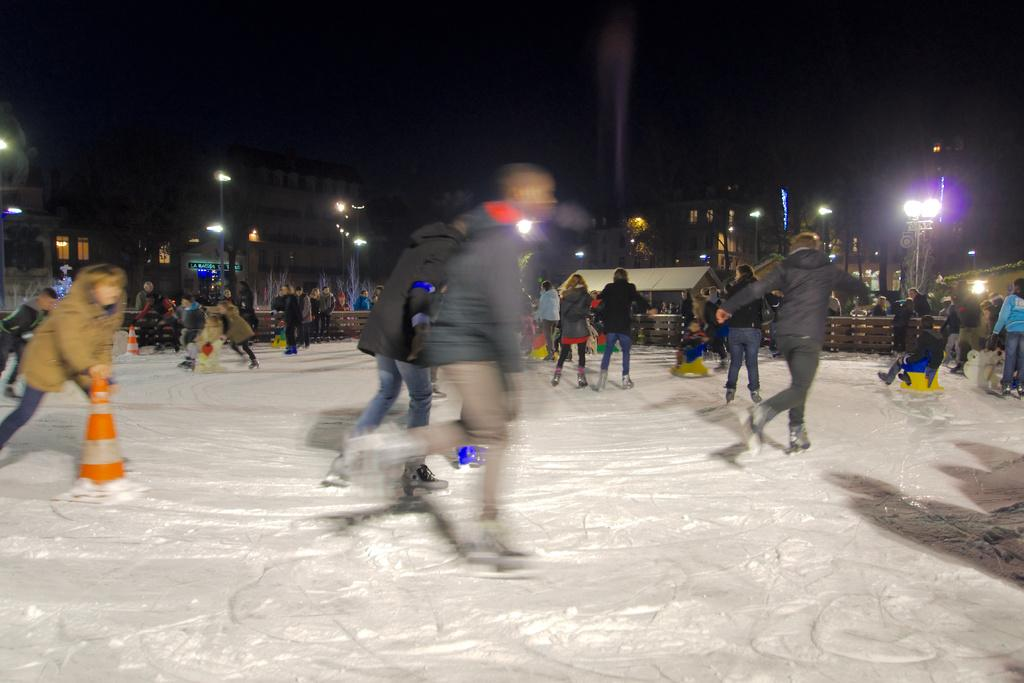What type of footwear are the people wearing in the image? The people are wearing ski shoes in the image. What objects are present in the foreground of the image? There are traffic cones and fencing in the foreground of the image. What can be seen in the background of the image? Buildings, lights, and boards are visible in the background of the image. What is the color of the background in the image? The background color is black. How does the fog affect the visibility of the people wearing ski shoes in the image? There is no fog present in the image, so it does not affect the visibility of the people wearing ski shoes. What type of cup is being used to hold the attention of the people in the image? There is no cup or attention-grabbing activity present in the image. 